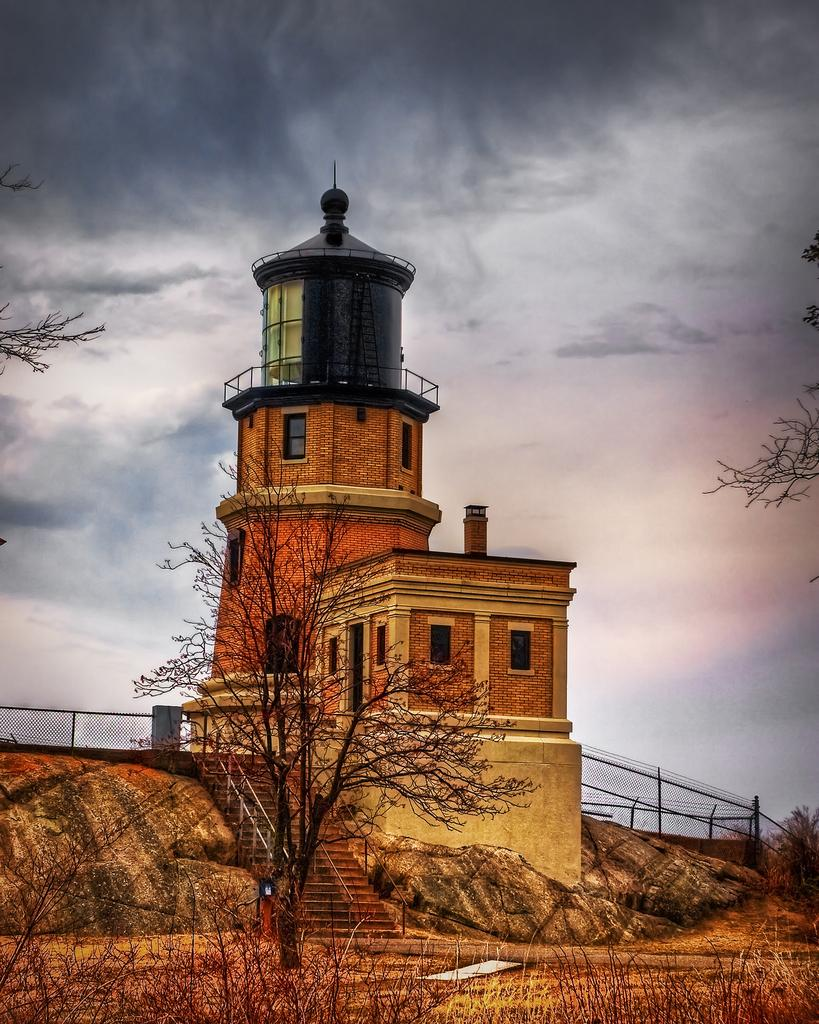What is the main structure in the center of the image? There is a building in the center of the image. What type of ground surface is visible at the bottom of the image? There is grass at the bottom of the image. What architectural feature is present at the bottom of the image? There are stairs at the bottom of the image. What can be seen in the background of the image? There are trees, a fence, and the sky visible in the background of the image. Where is the map located in the image? There is no map present in the image. Can you see a snake slithering through the grass in the image? There is no snake visible in the image. 